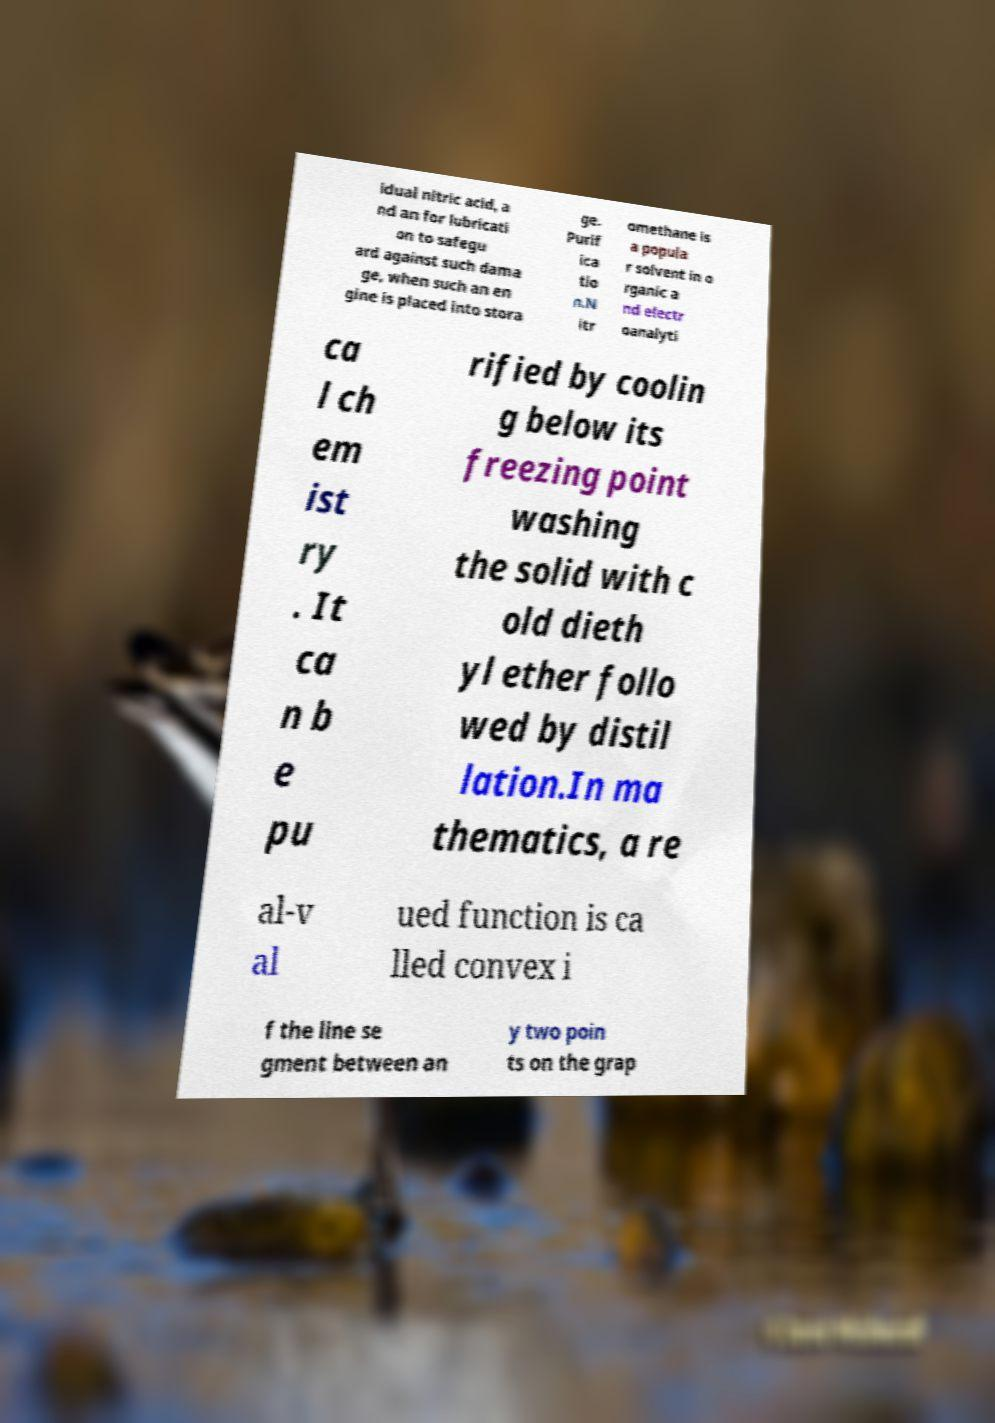Can you read and provide the text displayed in the image?This photo seems to have some interesting text. Can you extract and type it out for me? idual nitric acid, a nd an for lubricati on to safegu ard against such dama ge, when such an en gine is placed into stora ge. Purif ica tio n.N itr omethane is a popula r solvent in o rganic a nd electr oanalyti ca l ch em ist ry . It ca n b e pu rified by coolin g below its freezing point washing the solid with c old dieth yl ether follo wed by distil lation.In ma thematics, a re al-v al ued function is ca lled convex i f the line se gment between an y two poin ts on the grap 